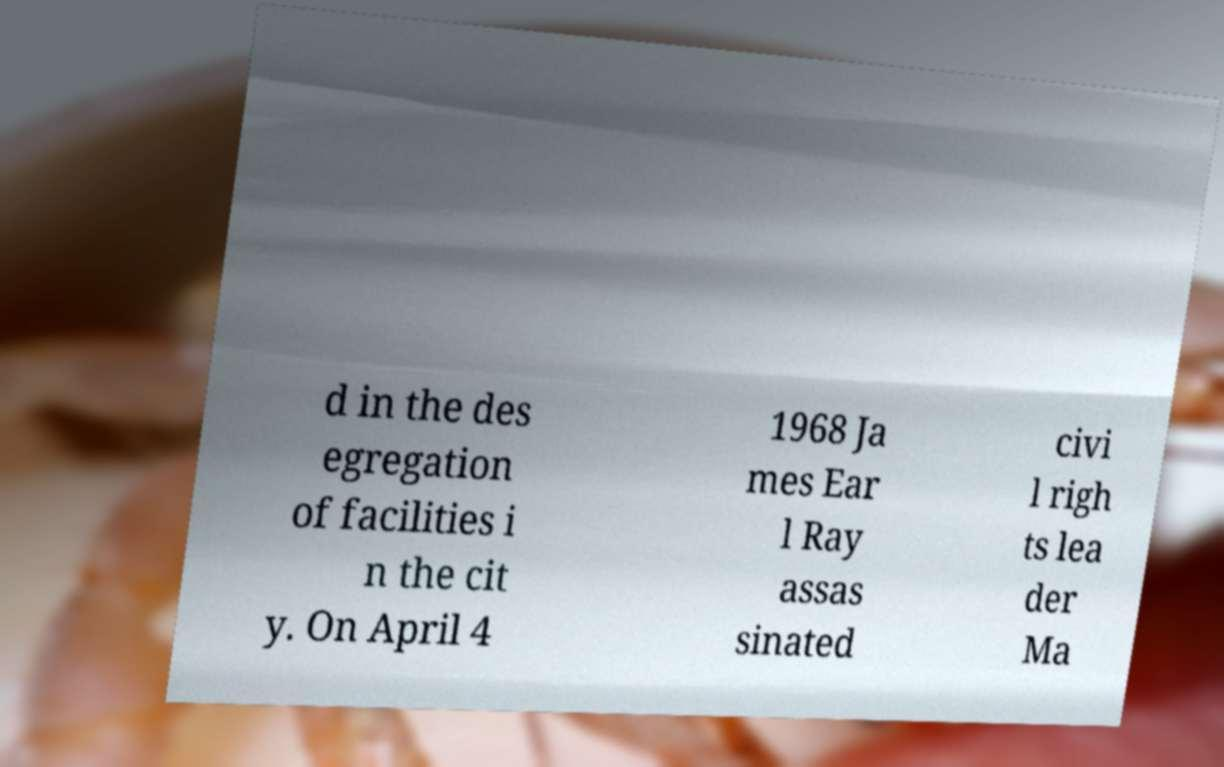What messages or text are displayed in this image? I need them in a readable, typed format. d in the des egregation of facilities i n the cit y. On April 4 1968 Ja mes Ear l Ray assas sinated civi l righ ts lea der Ma 